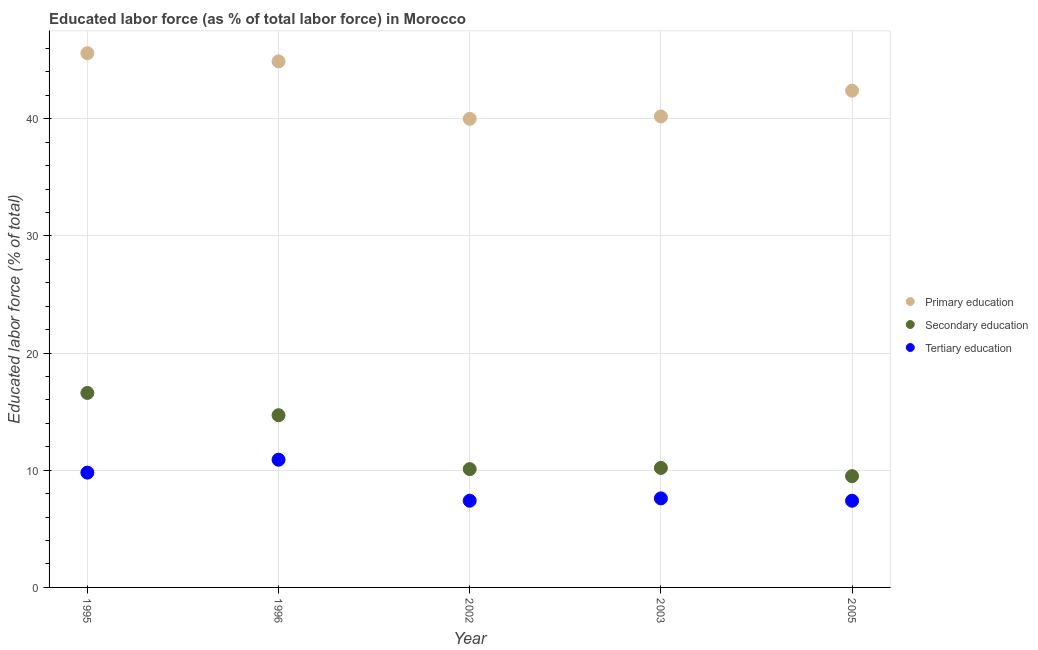What is the percentage of labor force who received secondary education in 2003?
Offer a very short reply. 10.2. Across all years, what is the maximum percentage of labor force who received primary education?
Your answer should be very brief. 45.6. Across all years, what is the minimum percentage of labor force who received tertiary education?
Make the answer very short. 7.4. What is the total percentage of labor force who received tertiary education in the graph?
Keep it short and to the point. 43.1. What is the difference between the percentage of labor force who received primary education in 1995 and that in 1996?
Your answer should be very brief. 0.7. What is the difference between the percentage of labor force who received secondary education in 2003 and the percentage of labor force who received tertiary education in 2002?
Offer a very short reply. 2.8. What is the average percentage of labor force who received tertiary education per year?
Keep it short and to the point. 8.62. In the year 2003, what is the difference between the percentage of labor force who received primary education and percentage of labor force who received tertiary education?
Ensure brevity in your answer.  32.6. In how many years, is the percentage of labor force who received tertiary education greater than 44 %?
Your answer should be compact. 0. What is the ratio of the percentage of labor force who received tertiary education in 1996 to that in 2003?
Your answer should be very brief. 1.43. What is the difference between the highest and the second highest percentage of labor force who received tertiary education?
Give a very brief answer. 1.1. What is the difference between the highest and the lowest percentage of labor force who received secondary education?
Keep it short and to the point. 7.1. Is the percentage of labor force who received secondary education strictly less than the percentage of labor force who received primary education over the years?
Keep it short and to the point. Yes. How many dotlines are there?
Ensure brevity in your answer.  3. What is the difference between two consecutive major ticks on the Y-axis?
Give a very brief answer. 10. Are the values on the major ticks of Y-axis written in scientific E-notation?
Your answer should be very brief. No. Does the graph contain grids?
Your answer should be very brief. Yes. How many legend labels are there?
Your answer should be very brief. 3. What is the title of the graph?
Provide a succinct answer. Educated labor force (as % of total labor force) in Morocco. Does "Ages 65 and above" appear as one of the legend labels in the graph?
Your response must be concise. No. What is the label or title of the Y-axis?
Keep it short and to the point. Educated labor force (% of total). What is the Educated labor force (% of total) of Primary education in 1995?
Offer a terse response. 45.6. What is the Educated labor force (% of total) of Secondary education in 1995?
Make the answer very short. 16.6. What is the Educated labor force (% of total) of Tertiary education in 1995?
Make the answer very short. 9.8. What is the Educated labor force (% of total) in Primary education in 1996?
Keep it short and to the point. 44.9. What is the Educated labor force (% of total) of Secondary education in 1996?
Offer a terse response. 14.7. What is the Educated labor force (% of total) in Tertiary education in 1996?
Provide a short and direct response. 10.9. What is the Educated labor force (% of total) of Primary education in 2002?
Your answer should be compact. 40. What is the Educated labor force (% of total) of Secondary education in 2002?
Provide a succinct answer. 10.1. What is the Educated labor force (% of total) of Tertiary education in 2002?
Make the answer very short. 7.4. What is the Educated labor force (% of total) of Primary education in 2003?
Make the answer very short. 40.2. What is the Educated labor force (% of total) of Secondary education in 2003?
Keep it short and to the point. 10.2. What is the Educated labor force (% of total) of Tertiary education in 2003?
Your response must be concise. 7.6. What is the Educated labor force (% of total) in Primary education in 2005?
Your answer should be very brief. 42.4. What is the Educated labor force (% of total) of Tertiary education in 2005?
Provide a succinct answer. 7.4. Across all years, what is the maximum Educated labor force (% of total) of Primary education?
Offer a very short reply. 45.6. Across all years, what is the maximum Educated labor force (% of total) of Secondary education?
Your response must be concise. 16.6. Across all years, what is the maximum Educated labor force (% of total) in Tertiary education?
Offer a very short reply. 10.9. Across all years, what is the minimum Educated labor force (% of total) of Secondary education?
Offer a very short reply. 9.5. Across all years, what is the minimum Educated labor force (% of total) of Tertiary education?
Ensure brevity in your answer.  7.4. What is the total Educated labor force (% of total) in Primary education in the graph?
Offer a very short reply. 213.1. What is the total Educated labor force (% of total) in Secondary education in the graph?
Your answer should be compact. 61.1. What is the total Educated labor force (% of total) of Tertiary education in the graph?
Your response must be concise. 43.1. What is the difference between the Educated labor force (% of total) of Tertiary education in 1995 and that in 1996?
Keep it short and to the point. -1.1. What is the difference between the Educated labor force (% of total) in Primary education in 1995 and that in 2002?
Ensure brevity in your answer.  5.6. What is the difference between the Educated labor force (% of total) of Secondary education in 1995 and that in 2002?
Keep it short and to the point. 6.5. What is the difference between the Educated labor force (% of total) of Tertiary education in 1995 and that in 2003?
Your answer should be compact. 2.2. What is the difference between the Educated labor force (% of total) of Secondary education in 1995 and that in 2005?
Ensure brevity in your answer.  7.1. What is the difference between the Educated labor force (% of total) in Primary education in 1996 and that in 2002?
Provide a succinct answer. 4.9. What is the difference between the Educated labor force (% of total) of Secondary education in 1996 and that in 2002?
Your answer should be compact. 4.6. What is the difference between the Educated labor force (% of total) in Primary education in 1996 and that in 2003?
Provide a succinct answer. 4.7. What is the difference between the Educated labor force (% of total) in Tertiary education in 1996 and that in 2003?
Your response must be concise. 3.3. What is the difference between the Educated labor force (% of total) in Primary education in 1996 and that in 2005?
Offer a very short reply. 2.5. What is the difference between the Educated labor force (% of total) of Secondary education in 1996 and that in 2005?
Offer a very short reply. 5.2. What is the difference between the Educated labor force (% of total) in Secondary education in 2002 and that in 2003?
Your answer should be compact. -0.1. What is the difference between the Educated labor force (% of total) of Secondary education in 2002 and that in 2005?
Provide a succinct answer. 0.6. What is the difference between the Educated labor force (% of total) in Primary education in 1995 and the Educated labor force (% of total) in Secondary education in 1996?
Provide a succinct answer. 30.9. What is the difference between the Educated labor force (% of total) of Primary education in 1995 and the Educated labor force (% of total) of Tertiary education in 1996?
Offer a terse response. 34.7. What is the difference between the Educated labor force (% of total) in Secondary education in 1995 and the Educated labor force (% of total) in Tertiary education in 1996?
Your response must be concise. 5.7. What is the difference between the Educated labor force (% of total) in Primary education in 1995 and the Educated labor force (% of total) in Secondary education in 2002?
Provide a succinct answer. 35.5. What is the difference between the Educated labor force (% of total) of Primary education in 1995 and the Educated labor force (% of total) of Tertiary education in 2002?
Your response must be concise. 38.2. What is the difference between the Educated labor force (% of total) in Primary education in 1995 and the Educated labor force (% of total) in Secondary education in 2003?
Offer a very short reply. 35.4. What is the difference between the Educated labor force (% of total) in Primary education in 1995 and the Educated labor force (% of total) in Secondary education in 2005?
Provide a short and direct response. 36.1. What is the difference between the Educated labor force (% of total) of Primary education in 1995 and the Educated labor force (% of total) of Tertiary education in 2005?
Provide a succinct answer. 38.2. What is the difference between the Educated labor force (% of total) in Secondary education in 1995 and the Educated labor force (% of total) in Tertiary education in 2005?
Ensure brevity in your answer.  9.2. What is the difference between the Educated labor force (% of total) in Primary education in 1996 and the Educated labor force (% of total) in Secondary education in 2002?
Ensure brevity in your answer.  34.8. What is the difference between the Educated labor force (% of total) in Primary education in 1996 and the Educated labor force (% of total) in Tertiary education in 2002?
Provide a succinct answer. 37.5. What is the difference between the Educated labor force (% of total) in Secondary education in 1996 and the Educated labor force (% of total) in Tertiary education in 2002?
Keep it short and to the point. 7.3. What is the difference between the Educated labor force (% of total) in Primary education in 1996 and the Educated labor force (% of total) in Secondary education in 2003?
Your answer should be very brief. 34.7. What is the difference between the Educated labor force (% of total) of Primary education in 1996 and the Educated labor force (% of total) of Tertiary education in 2003?
Offer a terse response. 37.3. What is the difference between the Educated labor force (% of total) of Primary education in 1996 and the Educated labor force (% of total) of Secondary education in 2005?
Make the answer very short. 35.4. What is the difference between the Educated labor force (% of total) of Primary education in 1996 and the Educated labor force (% of total) of Tertiary education in 2005?
Make the answer very short. 37.5. What is the difference between the Educated labor force (% of total) of Secondary education in 1996 and the Educated labor force (% of total) of Tertiary education in 2005?
Offer a terse response. 7.3. What is the difference between the Educated labor force (% of total) of Primary education in 2002 and the Educated labor force (% of total) of Secondary education in 2003?
Offer a terse response. 29.8. What is the difference between the Educated labor force (% of total) in Primary education in 2002 and the Educated labor force (% of total) in Tertiary education in 2003?
Provide a short and direct response. 32.4. What is the difference between the Educated labor force (% of total) in Primary education in 2002 and the Educated labor force (% of total) in Secondary education in 2005?
Provide a short and direct response. 30.5. What is the difference between the Educated labor force (% of total) of Primary education in 2002 and the Educated labor force (% of total) of Tertiary education in 2005?
Offer a terse response. 32.6. What is the difference between the Educated labor force (% of total) of Secondary education in 2002 and the Educated labor force (% of total) of Tertiary education in 2005?
Offer a very short reply. 2.7. What is the difference between the Educated labor force (% of total) in Primary education in 2003 and the Educated labor force (% of total) in Secondary education in 2005?
Your response must be concise. 30.7. What is the difference between the Educated labor force (% of total) of Primary education in 2003 and the Educated labor force (% of total) of Tertiary education in 2005?
Your response must be concise. 32.8. What is the difference between the Educated labor force (% of total) of Secondary education in 2003 and the Educated labor force (% of total) of Tertiary education in 2005?
Offer a terse response. 2.8. What is the average Educated labor force (% of total) in Primary education per year?
Offer a terse response. 42.62. What is the average Educated labor force (% of total) of Secondary education per year?
Offer a terse response. 12.22. What is the average Educated labor force (% of total) of Tertiary education per year?
Provide a succinct answer. 8.62. In the year 1995, what is the difference between the Educated labor force (% of total) in Primary education and Educated labor force (% of total) in Tertiary education?
Your answer should be very brief. 35.8. In the year 1996, what is the difference between the Educated labor force (% of total) of Primary education and Educated labor force (% of total) of Secondary education?
Make the answer very short. 30.2. In the year 1996, what is the difference between the Educated labor force (% of total) of Secondary education and Educated labor force (% of total) of Tertiary education?
Provide a short and direct response. 3.8. In the year 2002, what is the difference between the Educated labor force (% of total) of Primary education and Educated labor force (% of total) of Secondary education?
Offer a very short reply. 29.9. In the year 2002, what is the difference between the Educated labor force (% of total) of Primary education and Educated labor force (% of total) of Tertiary education?
Your response must be concise. 32.6. In the year 2002, what is the difference between the Educated labor force (% of total) in Secondary education and Educated labor force (% of total) in Tertiary education?
Provide a short and direct response. 2.7. In the year 2003, what is the difference between the Educated labor force (% of total) in Primary education and Educated labor force (% of total) in Secondary education?
Make the answer very short. 30. In the year 2003, what is the difference between the Educated labor force (% of total) in Primary education and Educated labor force (% of total) in Tertiary education?
Keep it short and to the point. 32.6. In the year 2003, what is the difference between the Educated labor force (% of total) of Secondary education and Educated labor force (% of total) of Tertiary education?
Keep it short and to the point. 2.6. In the year 2005, what is the difference between the Educated labor force (% of total) in Primary education and Educated labor force (% of total) in Secondary education?
Ensure brevity in your answer.  32.9. In the year 2005, what is the difference between the Educated labor force (% of total) in Secondary education and Educated labor force (% of total) in Tertiary education?
Keep it short and to the point. 2.1. What is the ratio of the Educated labor force (% of total) of Primary education in 1995 to that in 1996?
Your answer should be compact. 1.02. What is the ratio of the Educated labor force (% of total) of Secondary education in 1995 to that in 1996?
Make the answer very short. 1.13. What is the ratio of the Educated labor force (% of total) of Tertiary education in 1995 to that in 1996?
Make the answer very short. 0.9. What is the ratio of the Educated labor force (% of total) of Primary education in 1995 to that in 2002?
Your answer should be compact. 1.14. What is the ratio of the Educated labor force (% of total) in Secondary education in 1995 to that in 2002?
Your answer should be compact. 1.64. What is the ratio of the Educated labor force (% of total) of Tertiary education in 1995 to that in 2002?
Your response must be concise. 1.32. What is the ratio of the Educated labor force (% of total) in Primary education in 1995 to that in 2003?
Offer a very short reply. 1.13. What is the ratio of the Educated labor force (% of total) of Secondary education in 1995 to that in 2003?
Provide a short and direct response. 1.63. What is the ratio of the Educated labor force (% of total) of Tertiary education in 1995 to that in 2003?
Keep it short and to the point. 1.29. What is the ratio of the Educated labor force (% of total) of Primary education in 1995 to that in 2005?
Make the answer very short. 1.08. What is the ratio of the Educated labor force (% of total) of Secondary education in 1995 to that in 2005?
Your response must be concise. 1.75. What is the ratio of the Educated labor force (% of total) in Tertiary education in 1995 to that in 2005?
Give a very brief answer. 1.32. What is the ratio of the Educated labor force (% of total) of Primary education in 1996 to that in 2002?
Your answer should be very brief. 1.12. What is the ratio of the Educated labor force (% of total) of Secondary education in 1996 to that in 2002?
Provide a short and direct response. 1.46. What is the ratio of the Educated labor force (% of total) of Tertiary education in 1996 to that in 2002?
Keep it short and to the point. 1.47. What is the ratio of the Educated labor force (% of total) in Primary education in 1996 to that in 2003?
Give a very brief answer. 1.12. What is the ratio of the Educated labor force (% of total) in Secondary education in 1996 to that in 2003?
Keep it short and to the point. 1.44. What is the ratio of the Educated labor force (% of total) in Tertiary education in 1996 to that in 2003?
Your answer should be compact. 1.43. What is the ratio of the Educated labor force (% of total) in Primary education in 1996 to that in 2005?
Ensure brevity in your answer.  1.06. What is the ratio of the Educated labor force (% of total) in Secondary education in 1996 to that in 2005?
Provide a short and direct response. 1.55. What is the ratio of the Educated labor force (% of total) of Tertiary education in 1996 to that in 2005?
Keep it short and to the point. 1.47. What is the ratio of the Educated labor force (% of total) in Secondary education in 2002 to that in 2003?
Your response must be concise. 0.99. What is the ratio of the Educated labor force (% of total) of Tertiary education in 2002 to that in 2003?
Keep it short and to the point. 0.97. What is the ratio of the Educated labor force (% of total) of Primary education in 2002 to that in 2005?
Make the answer very short. 0.94. What is the ratio of the Educated labor force (% of total) of Secondary education in 2002 to that in 2005?
Your response must be concise. 1.06. What is the ratio of the Educated labor force (% of total) of Primary education in 2003 to that in 2005?
Your response must be concise. 0.95. What is the ratio of the Educated labor force (% of total) of Secondary education in 2003 to that in 2005?
Your answer should be compact. 1.07. What is the difference between the highest and the lowest Educated labor force (% of total) of Primary education?
Offer a terse response. 5.6. What is the difference between the highest and the lowest Educated labor force (% of total) of Secondary education?
Your answer should be very brief. 7.1. 